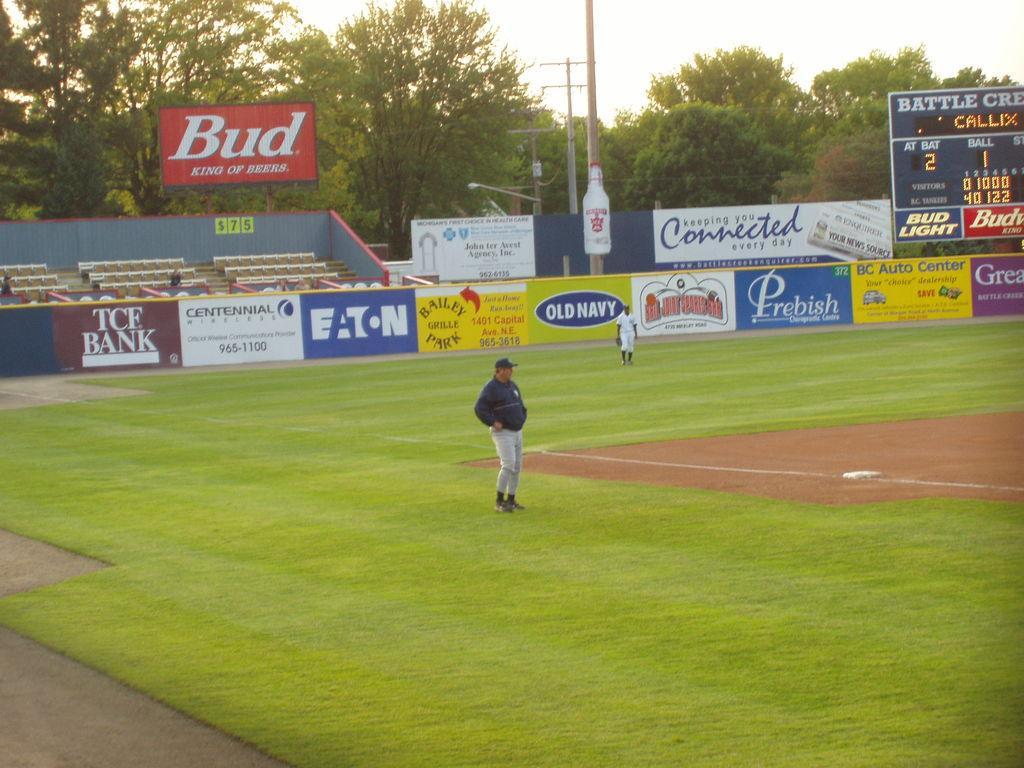Can you describe this image briefly? In the image we can see two people standing, wearing clothes and shoes, and one man is wearing a cap. Here we can see the grass, posters and text on the poster. We can even see there are chairs, electric poles and trees. We can see there are even other people wearing clothes. Here we can see the scoreboard and the sky. 